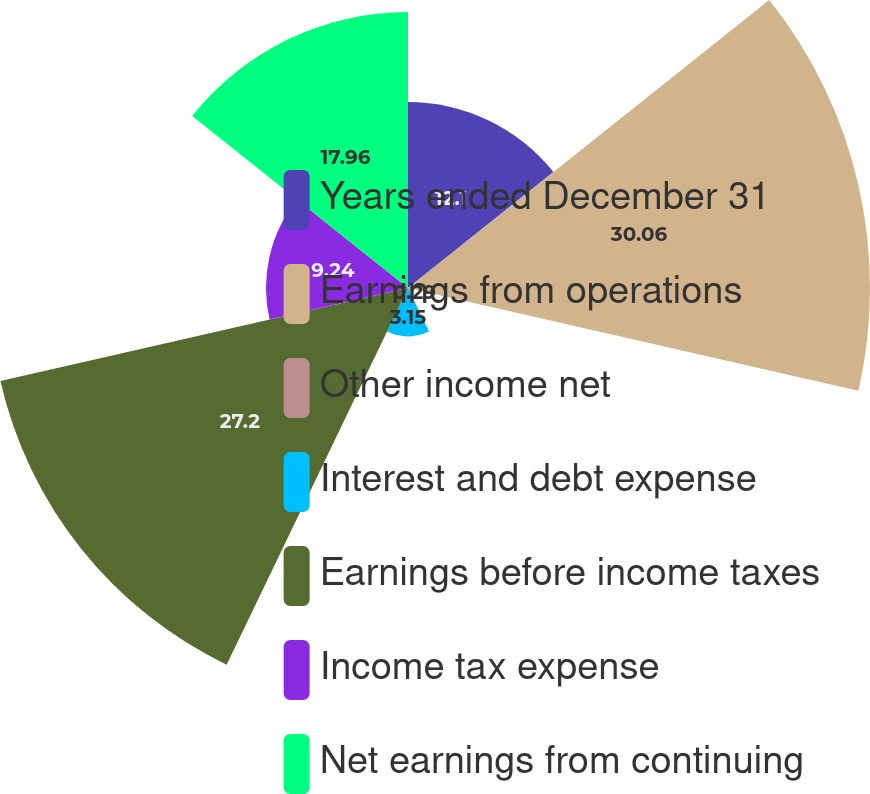Convert chart. <chart><loc_0><loc_0><loc_500><loc_500><pie_chart><fcel>Years ended December 31<fcel>Earnings from operations<fcel>Other income net<fcel>Interest and debt expense<fcel>Earnings before income taxes<fcel>Income tax expense<fcel>Net earnings from continuing<nl><fcel>12.1%<fcel>30.06%<fcel>0.29%<fcel>3.15%<fcel>27.2%<fcel>9.24%<fcel>17.96%<nl></chart> 